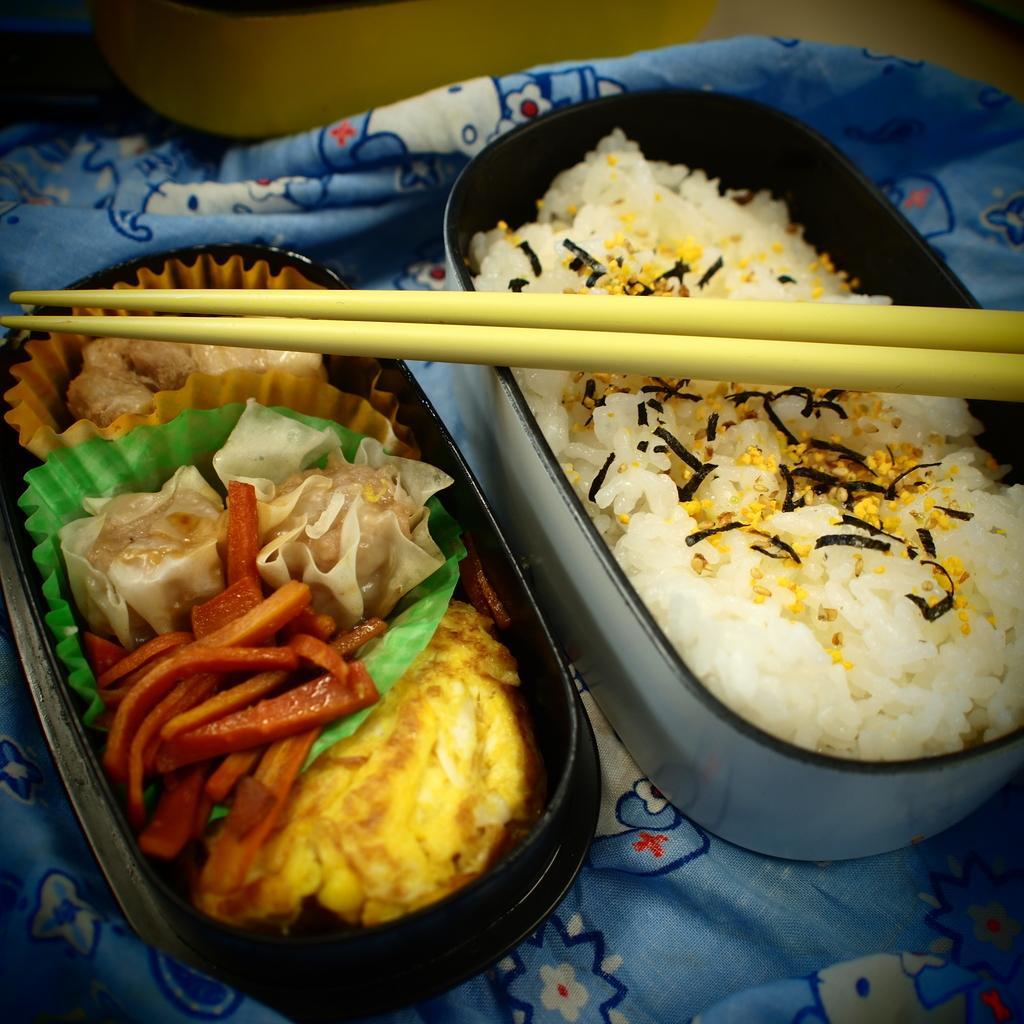Please provide a concise description of this image. In the picture we can see two boxes are placed on the blue color cloth in one box we can see rice, in one box we can see some vegetable salads and fries on it we can see two sticks. 